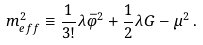Convert formula to latex. <formula><loc_0><loc_0><loc_500><loc_500>m ^ { 2 } _ { e f f } \equiv \frac { 1 } { 3 ! } \lambda \bar { \varphi } ^ { 2 } + \frac { 1 } { 2 } \lambda G - \mu ^ { 2 } \, .</formula> 